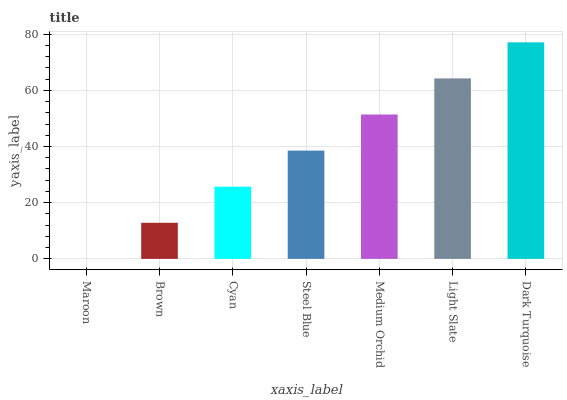Is Maroon the minimum?
Answer yes or no. Yes. Is Dark Turquoise the maximum?
Answer yes or no. Yes. Is Brown the minimum?
Answer yes or no. No. Is Brown the maximum?
Answer yes or no. No. Is Brown greater than Maroon?
Answer yes or no. Yes. Is Maroon less than Brown?
Answer yes or no. Yes. Is Maroon greater than Brown?
Answer yes or no. No. Is Brown less than Maroon?
Answer yes or no. No. Is Steel Blue the high median?
Answer yes or no. Yes. Is Steel Blue the low median?
Answer yes or no. Yes. Is Maroon the high median?
Answer yes or no. No. Is Medium Orchid the low median?
Answer yes or no. No. 